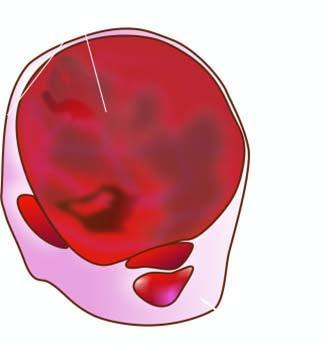what shows lobules of translucent gelatinous light brown parenchyma and areas of haemorrhage?
Answer the question using a single word or phrase. Cut section 